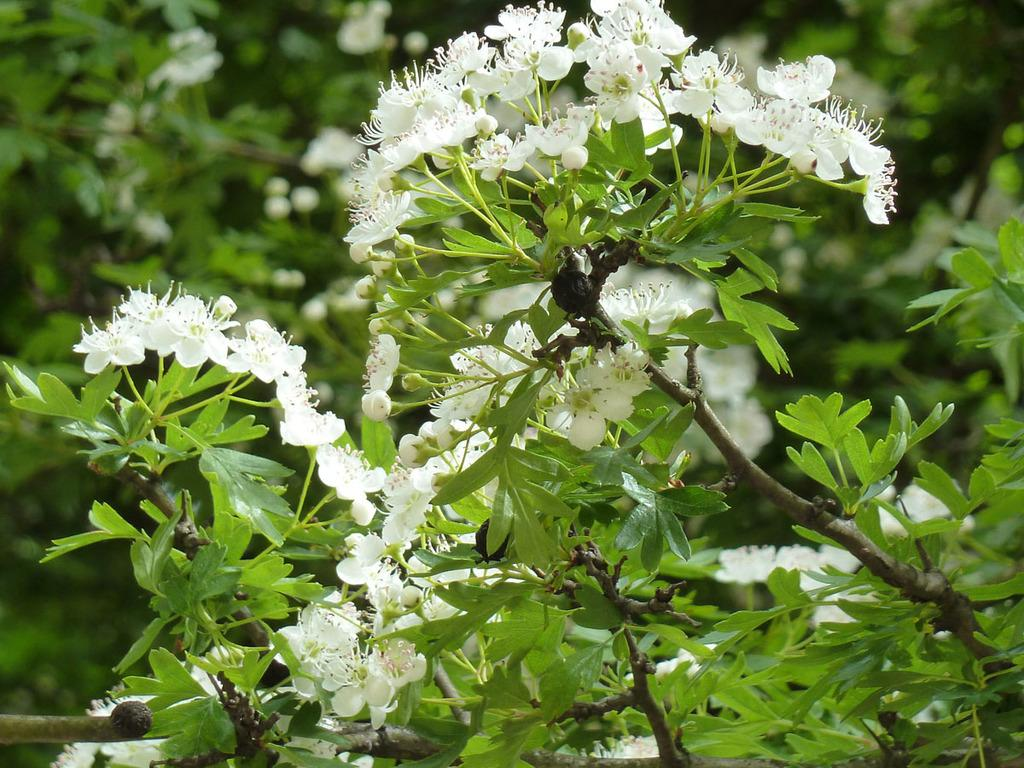What type of vegetation can be seen in the background of the image? There are green leaves and flowers in the background of the image. What is the main subject of the image? The image is mainly focused on a flower plant. What color are the flowers in the image? There are white flowers in the image. What stage of growth can be observed in the image? There are buds in the image. What type of cake is being served at the event in the image? There is no cake present in the image; it is focused on a flower plant with white flowers and green leaves in the background. What color is the dress worn by the horse in the image? There is no horse present in the image; it features a flower plant and vegetation in the background. 